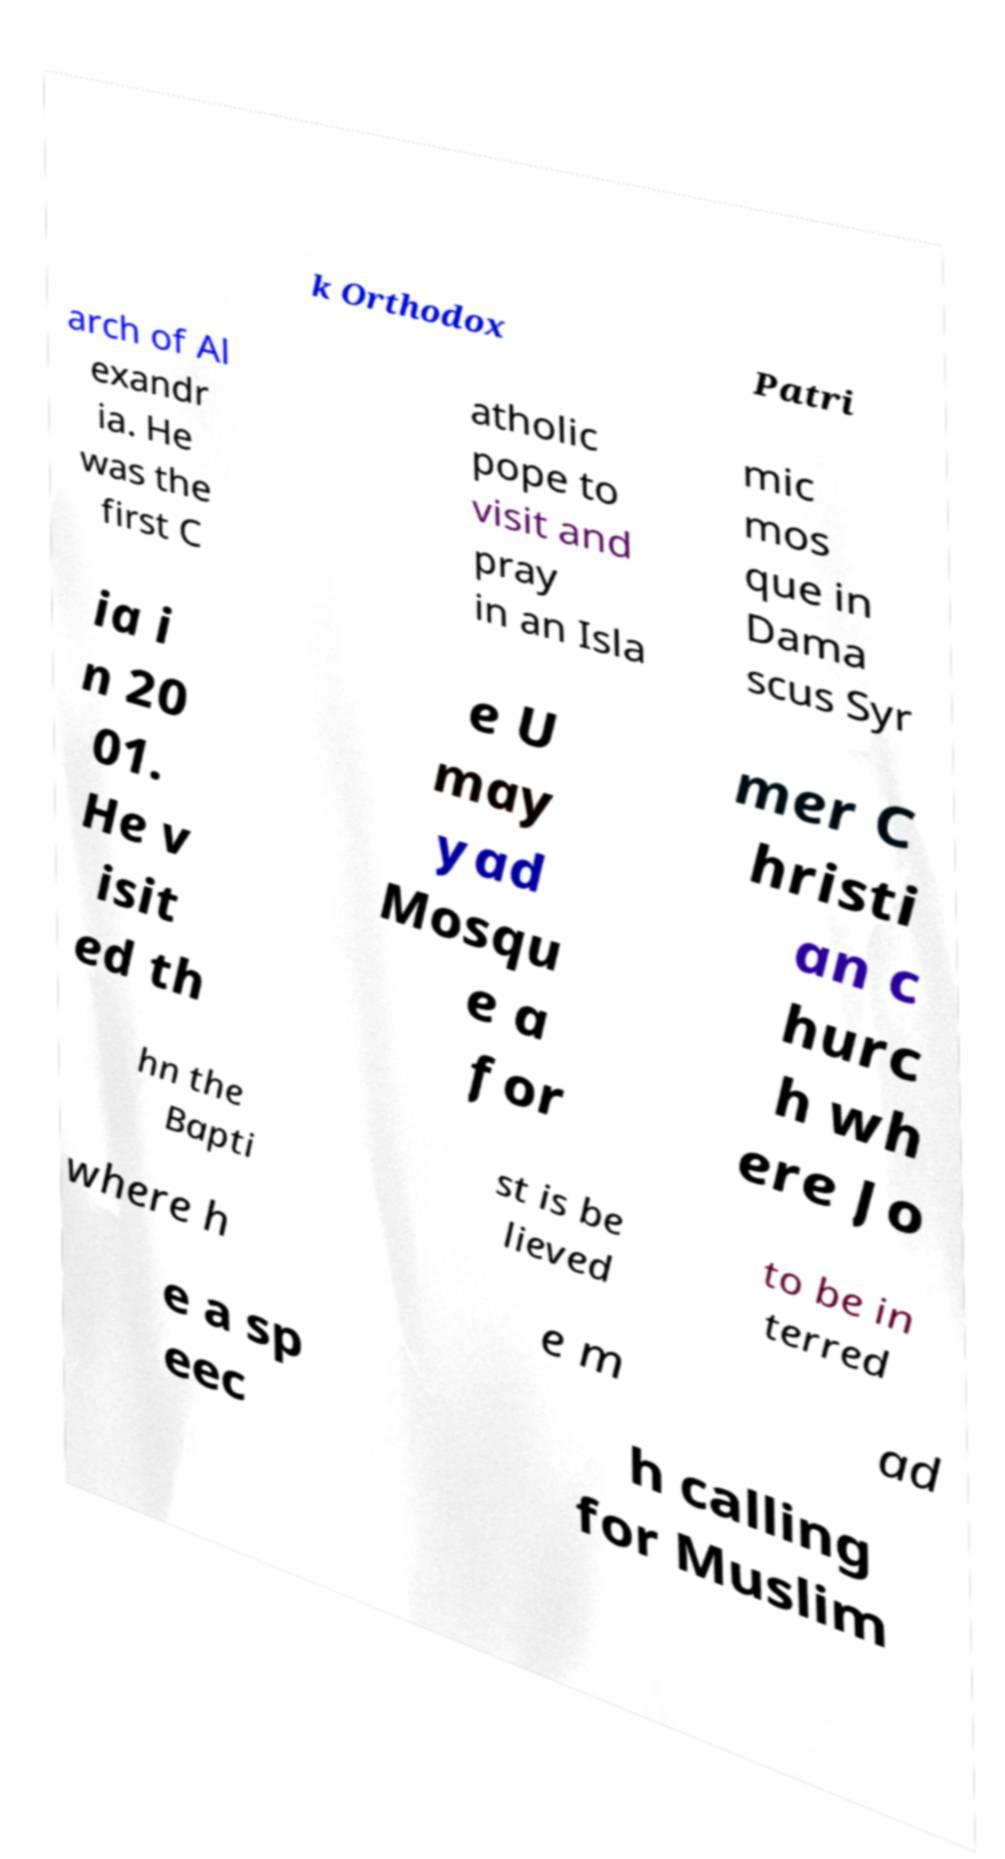I need the written content from this picture converted into text. Can you do that? k Orthodox Patri arch of Al exandr ia. He was the first C atholic pope to visit and pray in an Isla mic mos que in Dama scus Syr ia i n 20 01. He v isit ed th e U may yad Mosqu e a for mer C hristi an c hurc h wh ere Jo hn the Bapti st is be lieved to be in terred where h e m ad e a sp eec h calling for Muslim 